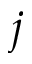Convert formula to latex. <formula><loc_0><loc_0><loc_500><loc_500>j</formula> 